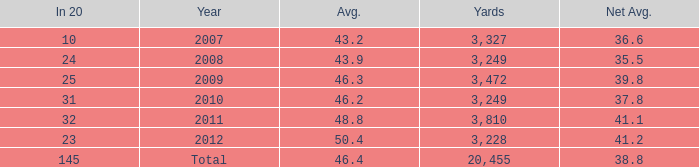What number of Yards has 32 as an In 20? 1.0. 